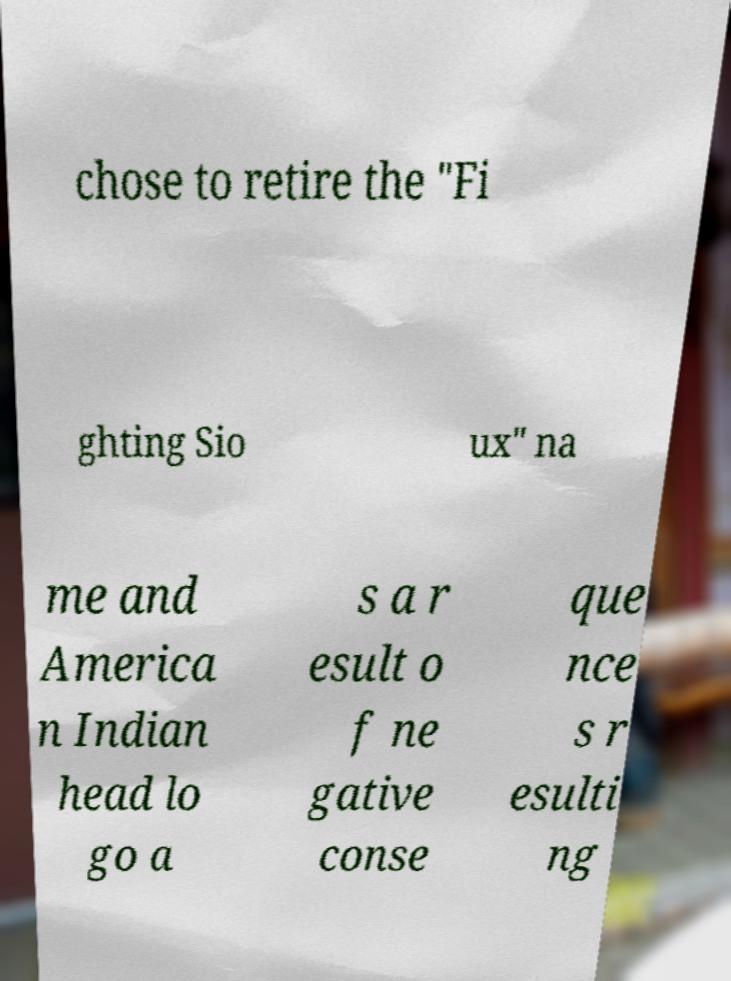Please identify and transcribe the text found in this image. chose to retire the "Fi ghting Sio ux" na me and America n Indian head lo go a s a r esult o f ne gative conse que nce s r esulti ng 